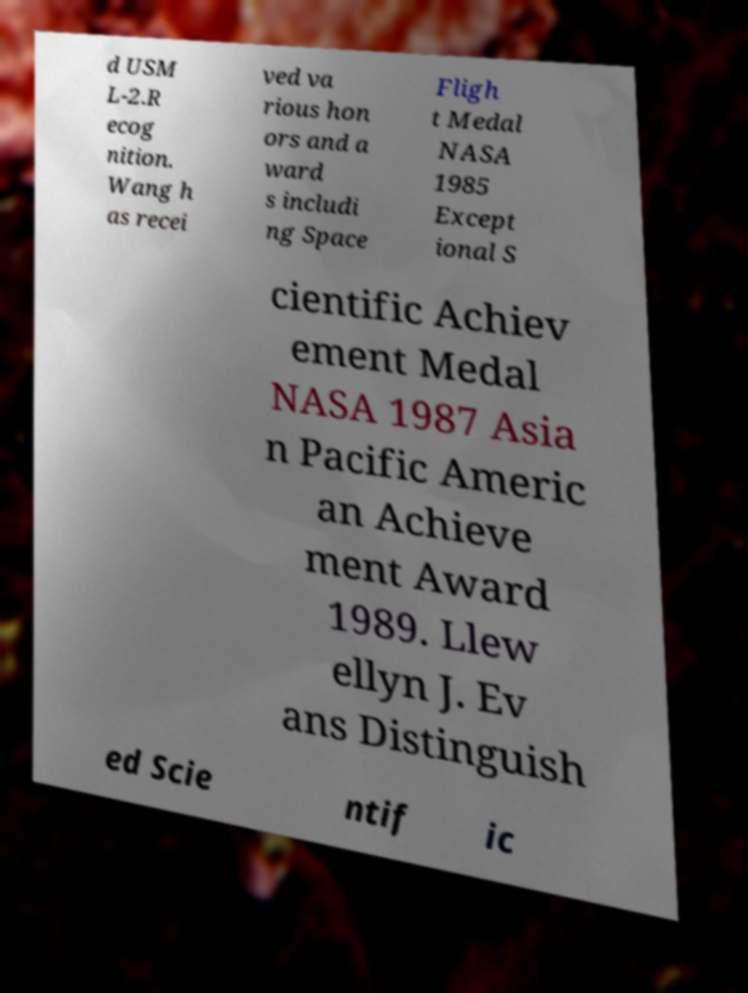I need the written content from this picture converted into text. Can you do that? d USM L-2.R ecog nition. Wang h as recei ved va rious hon ors and a ward s includi ng Space Fligh t Medal NASA 1985 Except ional S cientific Achiev ement Medal NASA 1987 Asia n Pacific Americ an Achieve ment Award 1989. Llew ellyn J. Ev ans Distinguish ed Scie ntif ic 